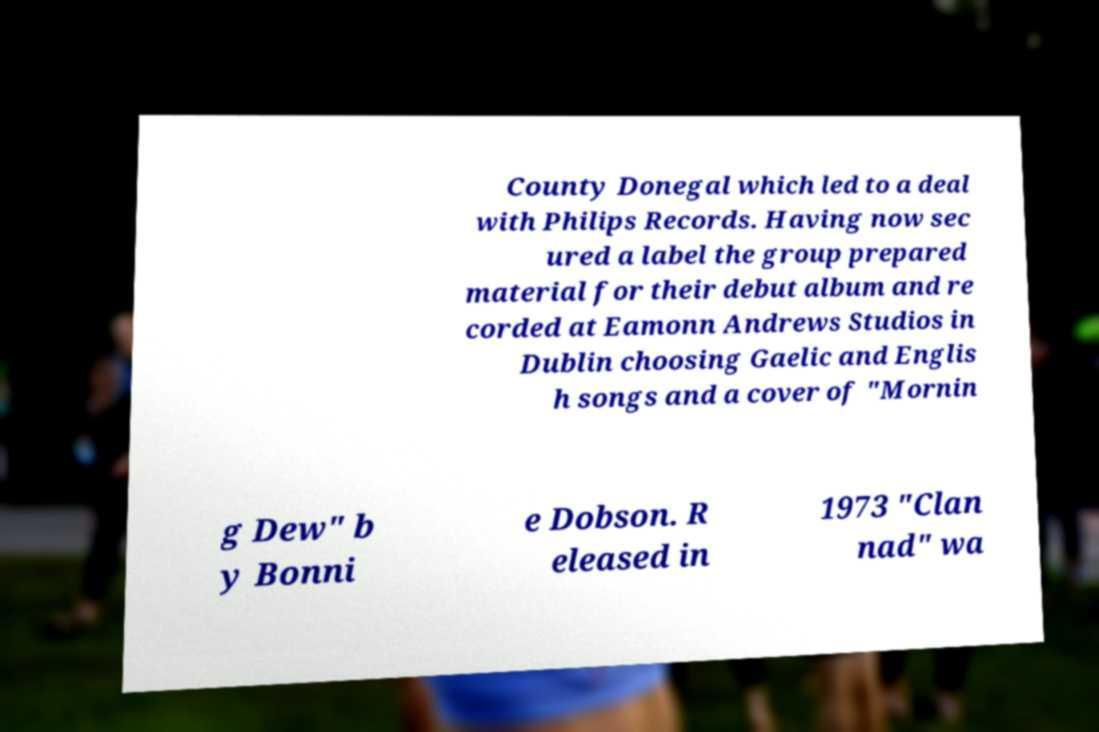Please identify and transcribe the text found in this image. County Donegal which led to a deal with Philips Records. Having now sec ured a label the group prepared material for their debut album and re corded at Eamonn Andrews Studios in Dublin choosing Gaelic and Englis h songs and a cover of "Mornin g Dew" b y Bonni e Dobson. R eleased in 1973 "Clan nad" wa 